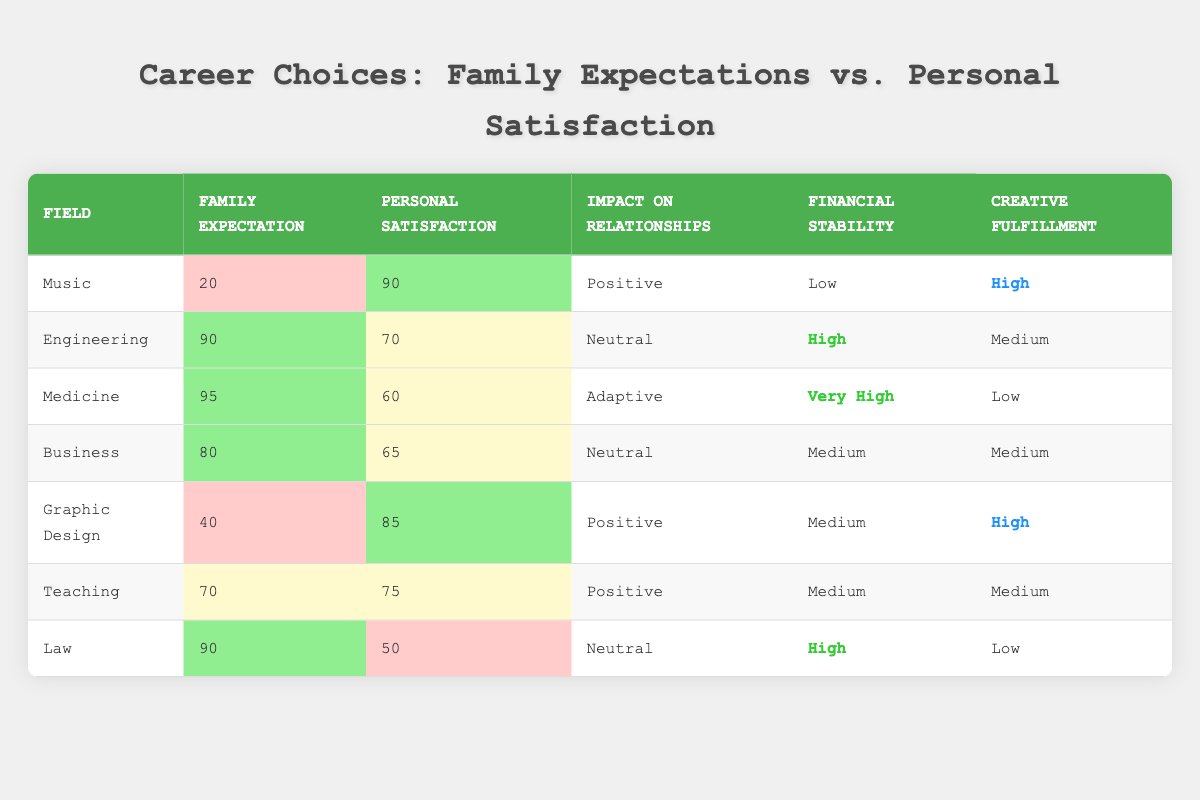What is the personal satisfaction score for a career in Music? The table shows that the personal satisfaction score for Music is 90.
Answer: 90 Which field has the highest family expectation score? The table indicates that Medicine has the highest family expectation score of 95.
Answer: 95 What is the impact on relationships for a career in Engineering? The table specifies that Engineering has a neutral impact on relationships.
Answer: Neutral Which career choice has the lowest financial stability? The table reveals that Music has low financial stability compared to other fields.
Answer: Music Is it true that Graphic Design offers high creative fulfillment? The table states that Graphic Design has high creative fulfillment, making this statement true.
Answer: Yes What is the average family expectation score for fields with medium financial stability? The fields with medium financial stability are Graphic Design, Business, and Teaching with scores of 40, 80, and 70 respectively. The average is (40 + 80 + 70) / 3 = 63.33.
Answer: 63.33 Which career has a personal satisfaction score less than 70? The table shows that Medicine and Law have personal satisfaction scores of 60 and 50, respectively, both less than 70.
Answer: Medicine and Law What is the difference between the personal satisfaction scores of Music and Medicine? The personal satisfaction score for Music is 90 and for Medicine is 60. The difference is 90 - 60 = 30.
Answer: 30 Which field has the best combination of high personal satisfaction and positive impact on relationships? Music has a personal satisfaction score of 90 and a positive impact on relationships, which is the best combination.
Answer: Music How many fields have a creative fulfillment rating of High? The fields with high creative fulfillment are Music and Graphic Design according to the table, totaling two fields.
Answer: 2 What is the median personal satisfaction score among the careers listed? The personal satisfaction scores are 90, 70, 60, 65, 85, 75, and 50. Sorting these gives: 50, 60, 65, 70, 75, 85, 90. The median is the middle value, which is 70.
Answer: 70 Which career choice has the highest financial stability and what score does it have? The table shows that Medicine has the highest financial stability with a score of "Very High."
Answer: Very High (Medicine) 